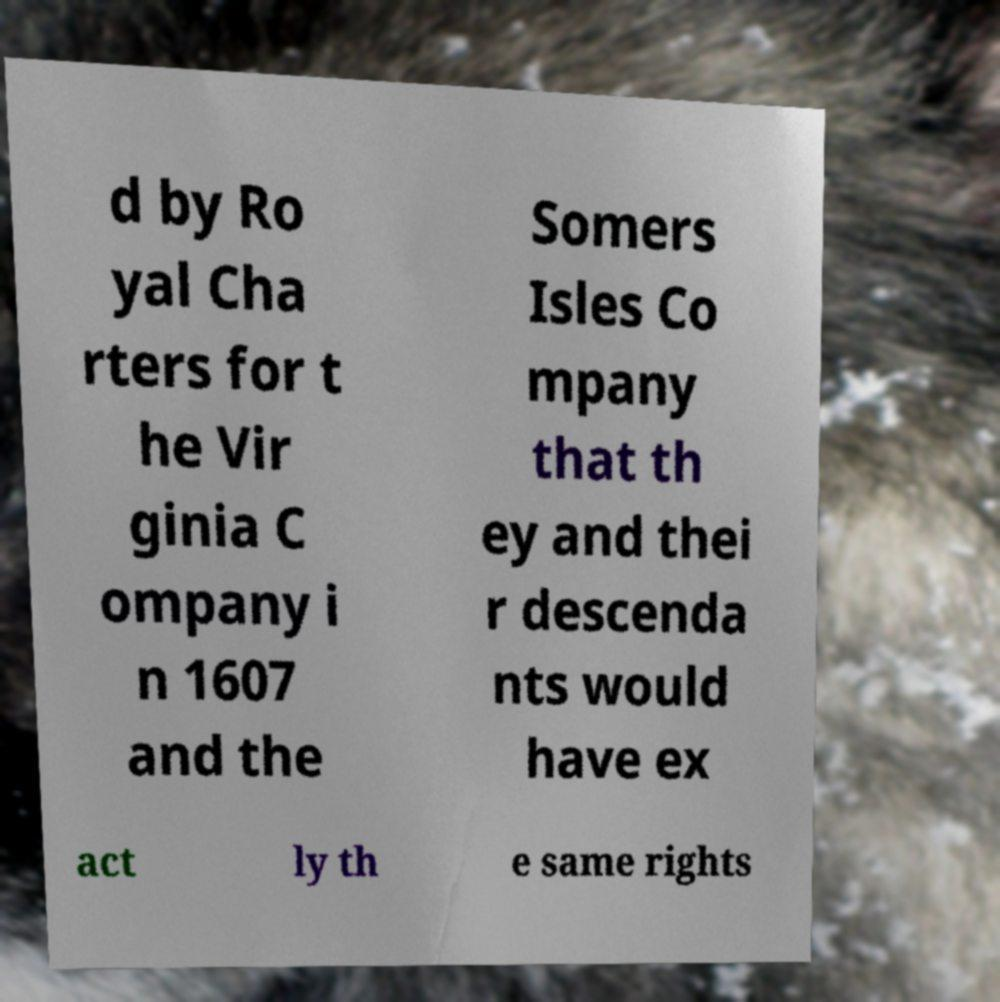For documentation purposes, I need the text within this image transcribed. Could you provide that? d by Ro yal Cha rters for t he Vir ginia C ompany i n 1607 and the Somers Isles Co mpany that th ey and thei r descenda nts would have ex act ly th e same rights 